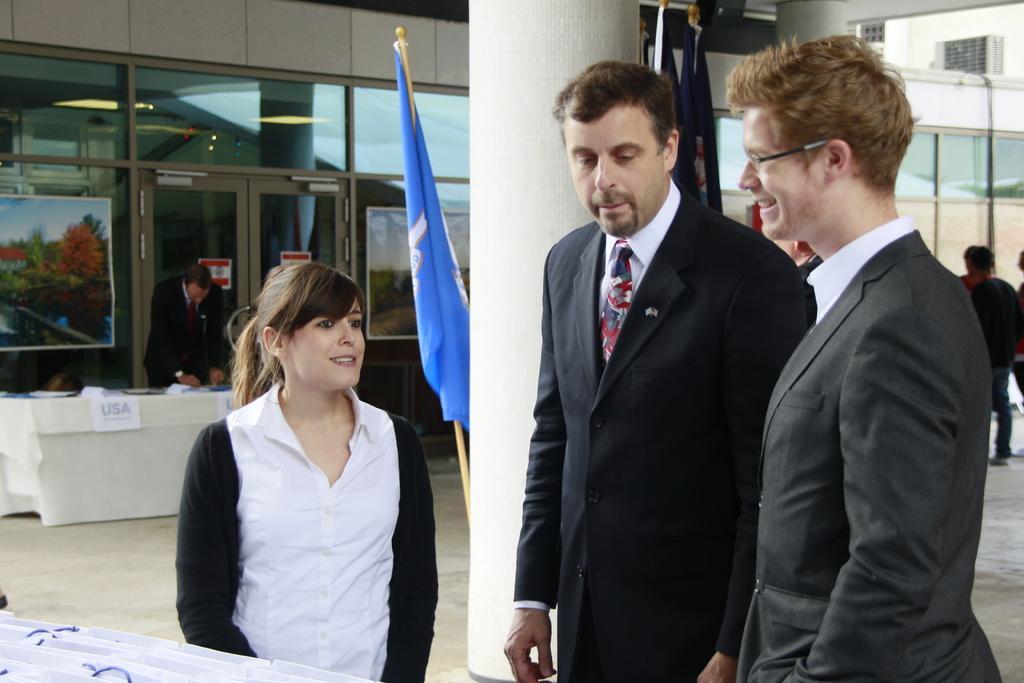Could you give a brief overview of what you see in this image? In this image we can see a woman and two men standing. On the backside we can see the flags, a pillar, a building, some people standing, a table with some papers on it, a building and some frames on the glass windows. 